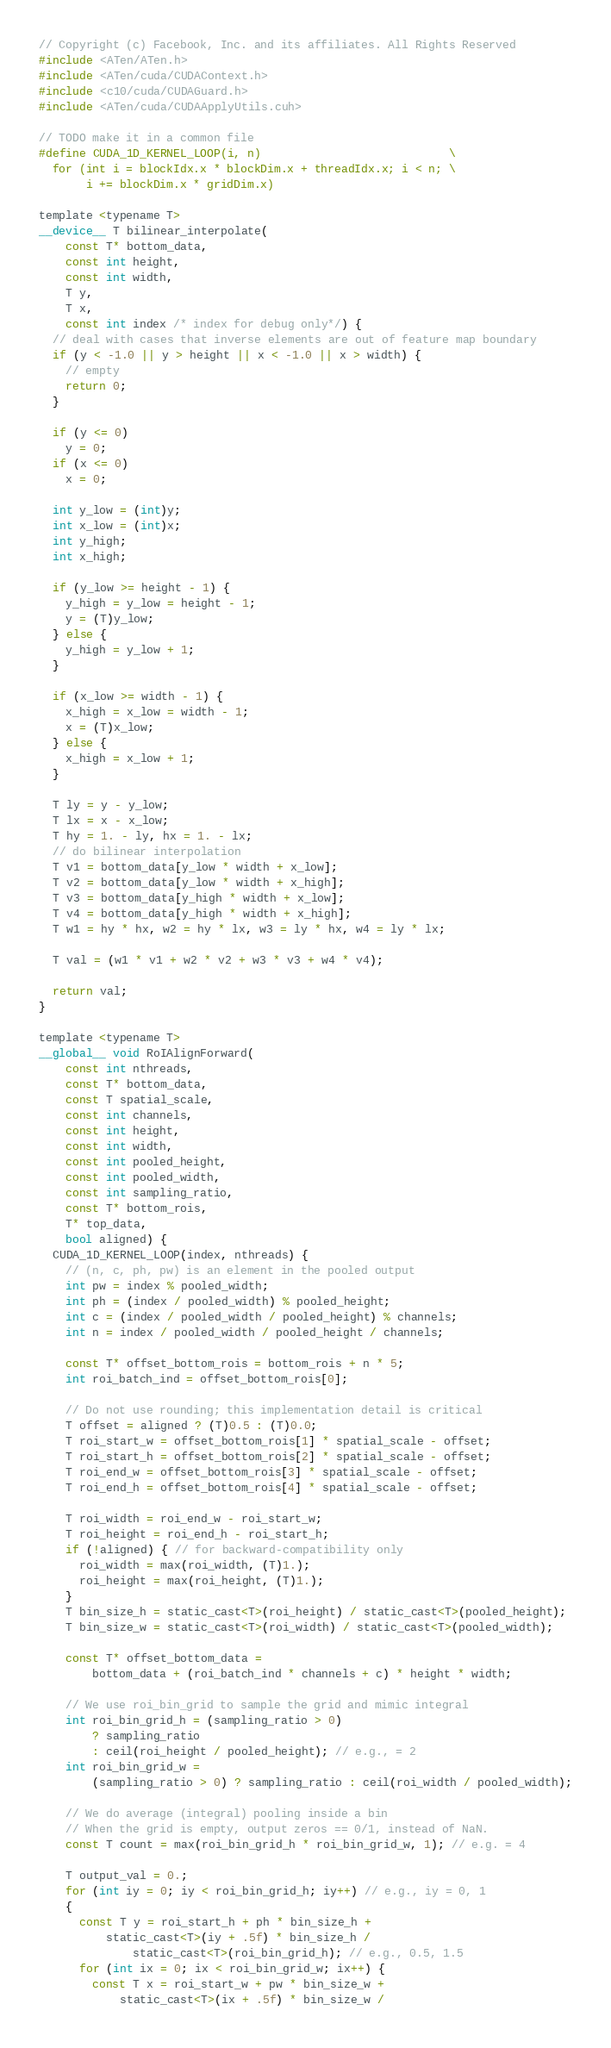Convert code to text. <code><loc_0><loc_0><loc_500><loc_500><_Cuda_>// Copyright (c) Facebook, Inc. and its affiliates. All Rights Reserved
#include <ATen/ATen.h>
#include <ATen/cuda/CUDAContext.h>
#include <c10/cuda/CUDAGuard.h>
#include <ATen/cuda/CUDAApplyUtils.cuh>

// TODO make it in a common file
#define CUDA_1D_KERNEL_LOOP(i, n)                            \
  for (int i = blockIdx.x * blockDim.x + threadIdx.x; i < n; \
       i += blockDim.x * gridDim.x)

template <typename T>
__device__ T bilinear_interpolate(
    const T* bottom_data,
    const int height,
    const int width,
    T y,
    T x,
    const int index /* index for debug only*/) {
  // deal with cases that inverse elements are out of feature map boundary
  if (y < -1.0 || y > height || x < -1.0 || x > width) {
    // empty
    return 0;
  }

  if (y <= 0)
    y = 0;
  if (x <= 0)
    x = 0;

  int y_low = (int)y;
  int x_low = (int)x;
  int y_high;
  int x_high;

  if (y_low >= height - 1) {
    y_high = y_low = height - 1;
    y = (T)y_low;
  } else {
    y_high = y_low + 1;
  }

  if (x_low >= width - 1) {
    x_high = x_low = width - 1;
    x = (T)x_low;
  } else {
    x_high = x_low + 1;
  }

  T ly = y - y_low;
  T lx = x - x_low;
  T hy = 1. - ly, hx = 1. - lx;
  // do bilinear interpolation
  T v1 = bottom_data[y_low * width + x_low];
  T v2 = bottom_data[y_low * width + x_high];
  T v3 = bottom_data[y_high * width + x_low];
  T v4 = bottom_data[y_high * width + x_high];
  T w1 = hy * hx, w2 = hy * lx, w3 = ly * hx, w4 = ly * lx;

  T val = (w1 * v1 + w2 * v2 + w3 * v3 + w4 * v4);

  return val;
}

template <typename T>
__global__ void RoIAlignForward(
    const int nthreads,
    const T* bottom_data,
    const T spatial_scale,
    const int channels,
    const int height,
    const int width,
    const int pooled_height,
    const int pooled_width,
    const int sampling_ratio,
    const T* bottom_rois,
    T* top_data,
    bool aligned) {
  CUDA_1D_KERNEL_LOOP(index, nthreads) {
    // (n, c, ph, pw) is an element in the pooled output
    int pw = index % pooled_width;
    int ph = (index / pooled_width) % pooled_height;
    int c = (index / pooled_width / pooled_height) % channels;
    int n = index / pooled_width / pooled_height / channels;

    const T* offset_bottom_rois = bottom_rois + n * 5;
    int roi_batch_ind = offset_bottom_rois[0];

    // Do not use rounding; this implementation detail is critical
    T offset = aligned ? (T)0.5 : (T)0.0;
    T roi_start_w = offset_bottom_rois[1] * spatial_scale - offset;
    T roi_start_h = offset_bottom_rois[2] * spatial_scale - offset;
    T roi_end_w = offset_bottom_rois[3] * spatial_scale - offset;
    T roi_end_h = offset_bottom_rois[4] * spatial_scale - offset;

    T roi_width = roi_end_w - roi_start_w;
    T roi_height = roi_end_h - roi_start_h;
    if (!aligned) { // for backward-compatibility only
      roi_width = max(roi_width, (T)1.);
      roi_height = max(roi_height, (T)1.);
    }
    T bin_size_h = static_cast<T>(roi_height) / static_cast<T>(pooled_height);
    T bin_size_w = static_cast<T>(roi_width) / static_cast<T>(pooled_width);

    const T* offset_bottom_data =
        bottom_data + (roi_batch_ind * channels + c) * height * width;

    // We use roi_bin_grid to sample the grid and mimic integral
    int roi_bin_grid_h = (sampling_ratio > 0)
        ? sampling_ratio
        : ceil(roi_height / pooled_height); // e.g., = 2
    int roi_bin_grid_w =
        (sampling_ratio > 0) ? sampling_ratio : ceil(roi_width / pooled_width);

    // We do average (integral) pooling inside a bin
    // When the grid is empty, output zeros == 0/1, instead of NaN.
    const T count = max(roi_bin_grid_h * roi_bin_grid_w, 1); // e.g. = 4

    T output_val = 0.;
    for (int iy = 0; iy < roi_bin_grid_h; iy++) // e.g., iy = 0, 1
    {
      const T y = roi_start_h + ph * bin_size_h +
          static_cast<T>(iy + .5f) * bin_size_h /
              static_cast<T>(roi_bin_grid_h); // e.g., 0.5, 1.5
      for (int ix = 0; ix < roi_bin_grid_w; ix++) {
        const T x = roi_start_w + pw * bin_size_w +
            static_cast<T>(ix + .5f) * bin_size_w /</code> 